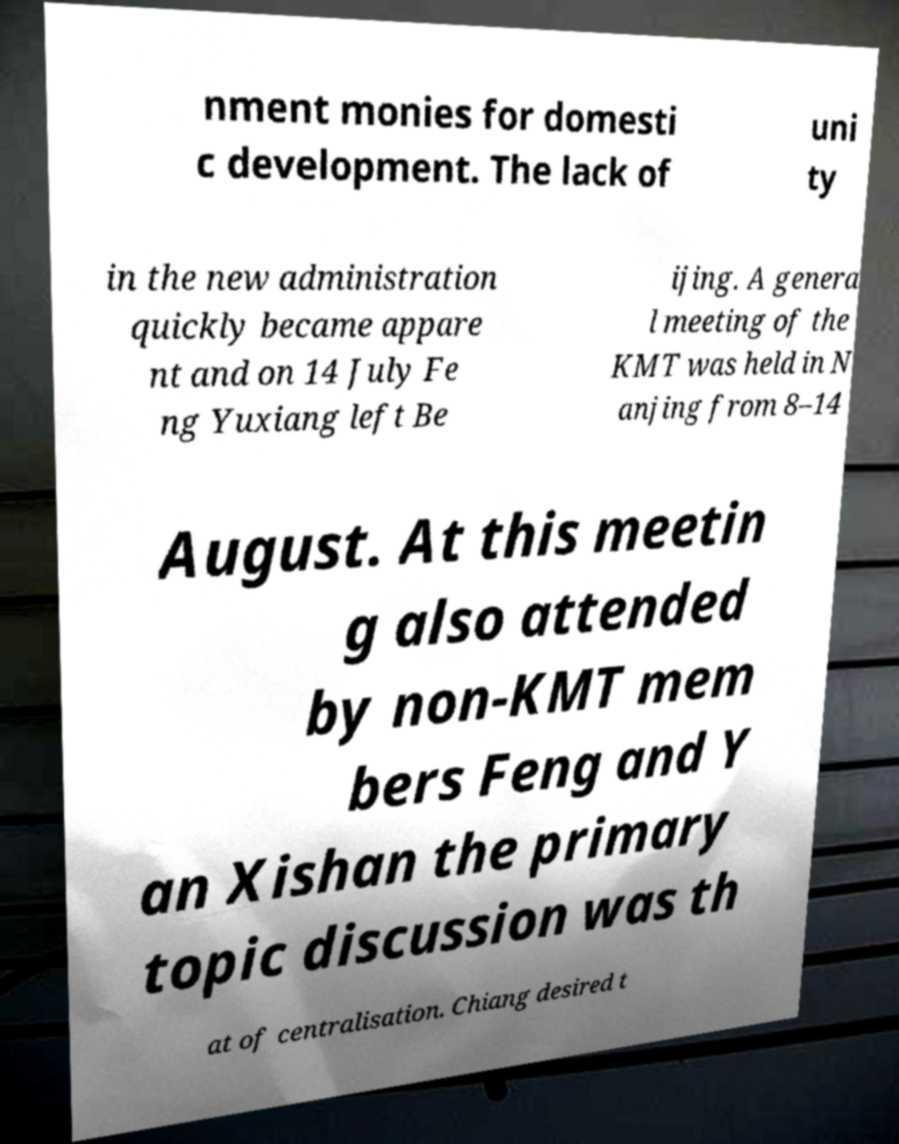Please identify and transcribe the text found in this image. nment monies for domesti c development. The lack of uni ty in the new administration quickly became appare nt and on 14 July Fe ng Yuxiang left Be ijing. A genera l meeting of the KMT was held in N anjing from 8–14 August. At this meetin g also attended by non-KMT mem bers Feng and Y an Xishan the primary topic discussion was th at of centralisation. Chiang desired t 